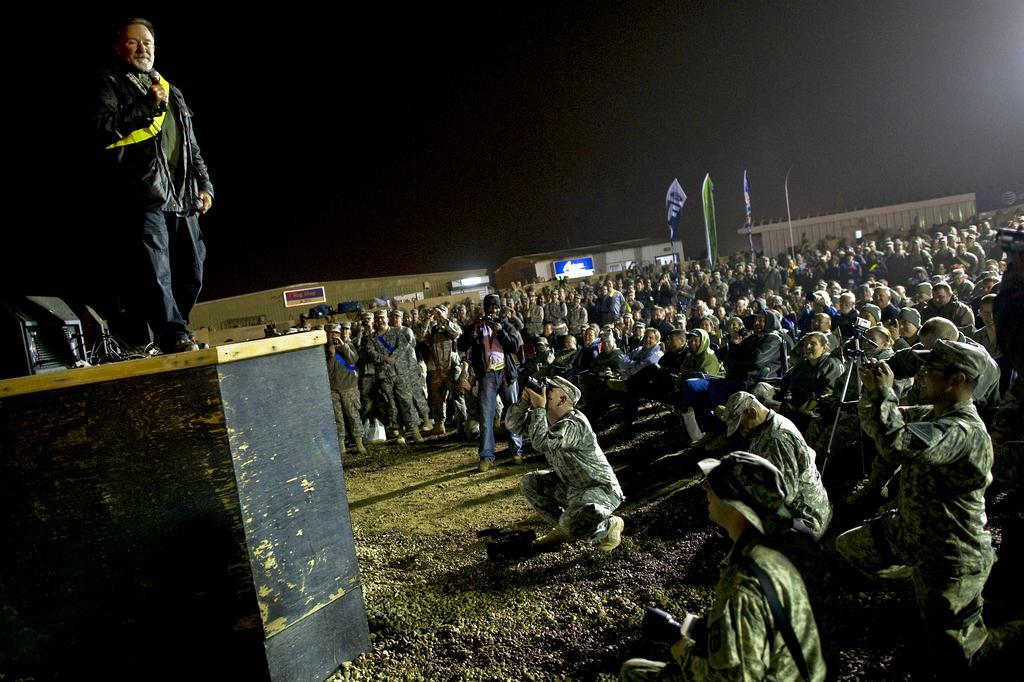Describe this image in one or two sentences. This is the man standing and holding a mike. This looks like a wooden stage. There are group of people sitting and standing. I can see few people holding a camera and clicking pictures. These are the flags hanging to the poles. I can see the name boards attached to the walls. I think these are the houses. This looks like a speaker, which is black in color. 